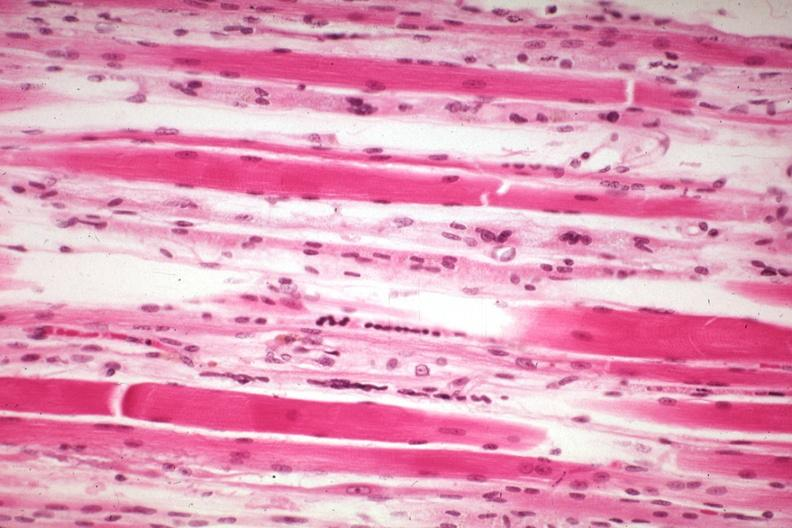what does this image show?
Answer the question using a single word or phrase. High excellent atrophy secondary to steroid therapy 